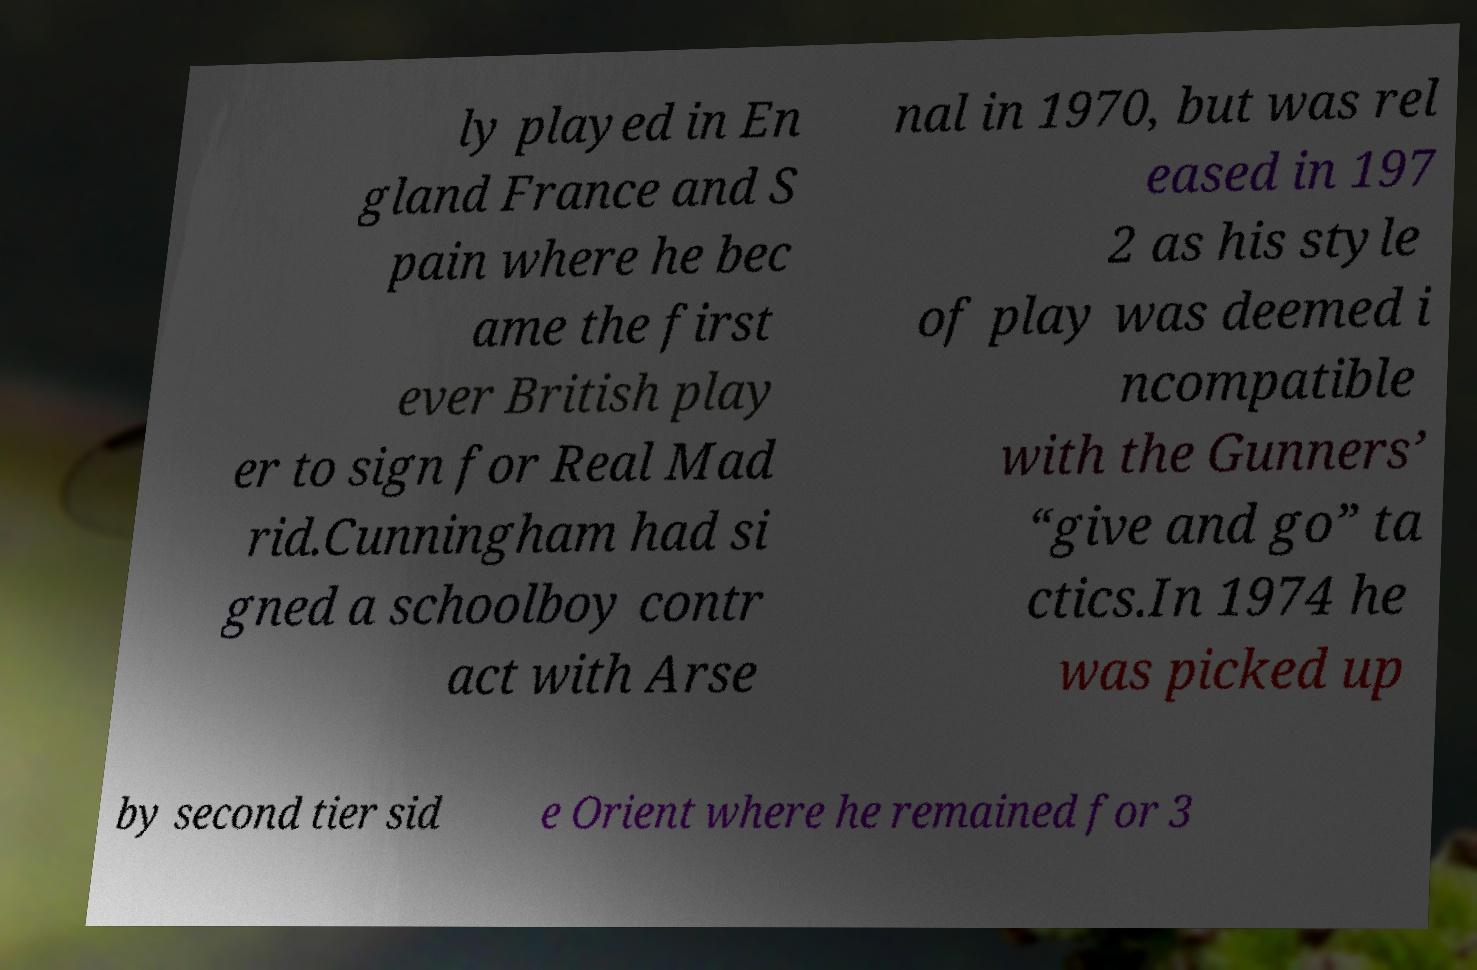Can you read and provide the text displayed in the image?This photo seems to have some interesting text. Can you extract and type it out for me? ly played in En gland France and S pain where he bec ame the first ever British play er to sign for Real Mad rid.Cunningham had si gned a schoolboy contr act with Arse nal in 1970, but was rel eased in 197 2 as his style of play was deemed i ncompatible with the Gunners’ “give and go” ta ctics.In 1974 he was picked up by second tier sid e Orient where he remained for 3 